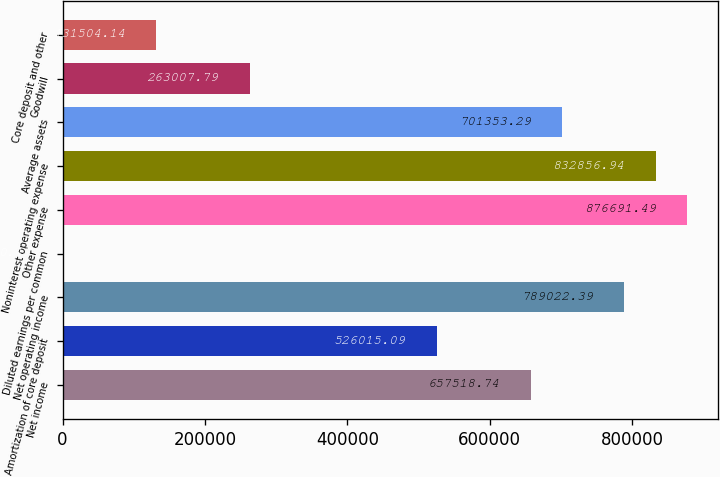Convert chart to OTSL. <chart><loc_0><loc_0><loc_500><loc_500><bar_chart><fcel>Net income<fcel>Amortization of core deposit<fcel>Net operating income<fcel>Diluted earnings per common<fcel>Other expense<fcel>Noninterest operating expense<fcel>Average assets<fcel>Goodwill<fcel>Core deposit and other<nl><fcel>657519<fcel>526015<fcel>789022<fcel>0.49<fcel>876691<fcel>832857<fcel>701353<fcel>263008<fcel>131504<nl></chart> 